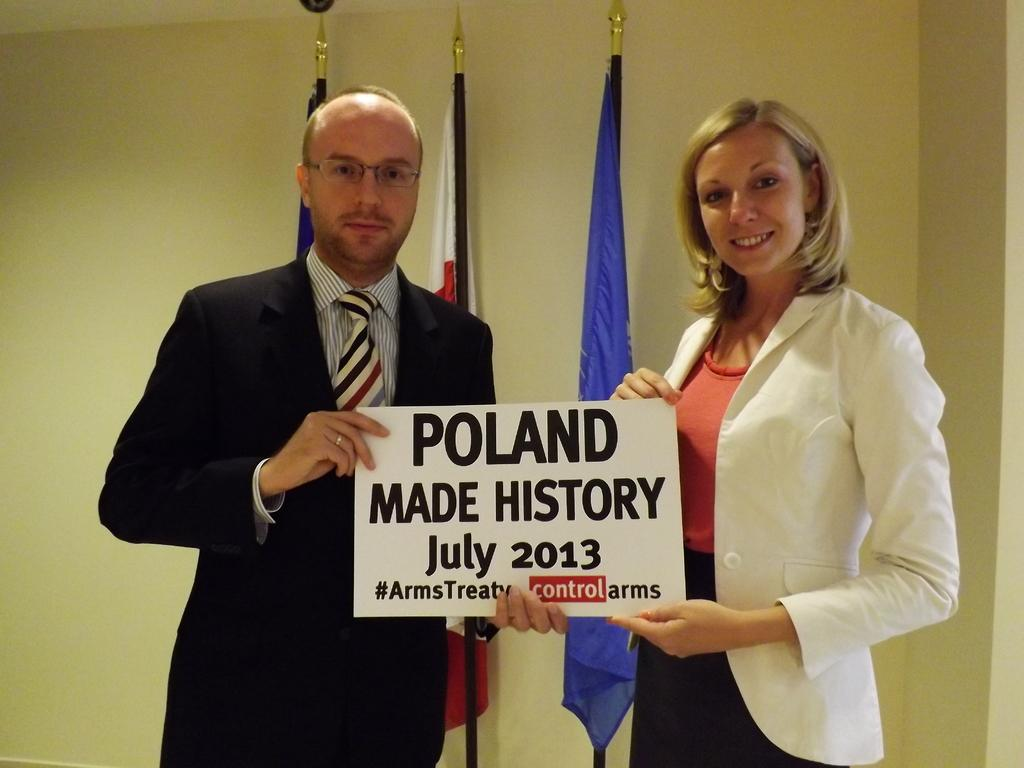Who are the people in the image? There is a man and a woman in the image. What are the man and woman doing in the image? The man and woman are standing and holding a board in their hands. What can be seen hanging on poles in the image? There are flags hanging on poles in the image. What is visible in the background of the image? There is a wall in the background of the image. What is the weight of the honey being used by the man and woman in the image? There is no honey present in the image, so it is not possible to determine its weight. 